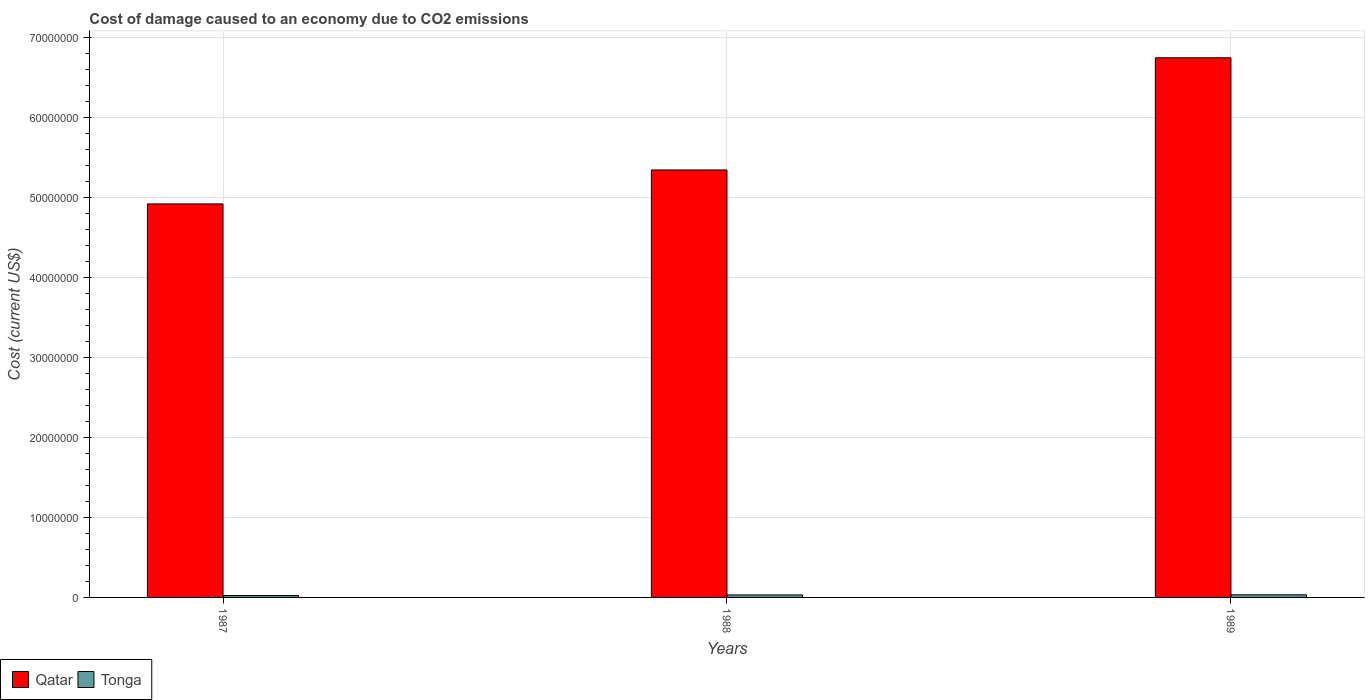How many different coloured bars are there?
Provide a short and direct response. 2. Are the number of bars per tick equal to the number of legend labels?
Make the answer very short. Yes. Are the number of bars on each tick of the X-axis equal?
Provide a succinct answer. Yes. How many bars are there on the 3rd tick from the left?
Ensure brevity in your answer.  2. How many bars are there on the 2nd tick from the right?
Offer a terse response. 2. In how many cases, is the number of bars for a given year not equal to the number of legend labels?
Make the answer very short. 0. What is the cost of damage caused due to CO2 emissisons in Tonga in 1989?
Your answer should be very brief. 3.28e+05. Across all years, what is the maximum cost of damage caused due to CO2 emissisons in Qatar?
Your response must be concise. 6.75e+07. Across all years, what is the minimum cost of damage caused due to CO2 emissisons in Qatar?
Your answer should be compact. 4.92e+07. In which year was the cost of damage caused due to CO2 emissisons in Qatar maximum?
Keep it short and to the point. 1989. In which year was the cost of damage caused due to CO2 emissisons in Qatar minimum?
Give a very brief answer. 1987. What is the total cost of damage caused due to CO2 emissisons in Qatar in the graph?
Give a very brief answer. 1.70e+08. What is the difference between the cost of damage caused due to CO2 emissisons in Qatar in 1987 and that in 1988?
Make the answer very short. -4.24e+06. What is the difference between the cost of damage caused due to CO2 emissisons in Tonga in 1987 and the cost of damage caused due to CO2 emissisons in Qatar in 1989?
Ensure brevity in your answer.  -6.72e+07. What is the average cost of damage caused due to CO2 emissisons in Tonga per year?
Offer a terse response. 2.92e+05. In the year 1989, what is the difference between the cost of damage caused due to CO2 emissisons in Tonga and cost of damage caused due to CO2 emissisons in Qatar?
Give a very brief answer. -6.71e+07. What is the ratio of the cost of damage caused due to CO2 emissisons in Tonga in 1987 to that in 1989?
Offer a very short reply. 0.72. Is the difference between the cost of damage caused due to CO2 emissisons in Tonga in 1988 and 1989 greater than the difference between the cost of damage caused due to CO2 emissisons in Qatar in 1988 and 1989?
Provide a short and direct response. Yes. What is the difference between the highest and the second highest cost of damage caused due to CO2 emissisons in Qatar?
Keep it short and to the point. 1.40e+07. What is the difference between the highest and the lowest cost of damage caused due to CO2 emissisons in Tonga?
Offer a very short reply. 9.28e+04. In how many years, is the cost of damage caused due to CO2 emissisons in Tonga greater than the average cost of damage caused due to CO2 emissisons in Tonga taken over all years?
Offer a very short reply. 2. Is the sum of the cost of damage caused due to CO2 emissisons in Qatar in 1987 and 1988 greater than the maximum cost of damage caused due to CO2 emissisons in Tonga across all years?
Your response must be concise. Yes. What does the 2nd bar from the left in 1988 represents?
Your answer should be very brief. Tonga. What does the 2nd bar from the right in 1987 represents?
Provide a short and direct response. Qatar. Are all the bars in the graph horizontal?
Your answer should be compact. No. How many years are there in the graph?
Offer a terse response. 3. Are the values on the major ticks of Y-axis written in scientific E-notation?
Provide a succinct answer. No. Does the graph contain any zero values?
Keep it short and to the point. No. Does the graph contain grids?
Ensure brevity in your answer.  Yes. How are the legend labels stacked?
Make the answer very short. Horizontal. What is the title of the graph?
Provide a short and direct response. Cost of damage caused to an economy due to CO2 emissions. What is the label or title of the Y-axis?
Provide a succinct answer. Cost (current US$). What is the Cost (current US$) in Qatar in 1987?
Offer a terse response. 4.92e+07. What is the Cost (current US$) in Tonga in 1987?
Provide a succinct answer. 2.35e+05. What is the Cost (current US$) of Qatar in 1988?
Keep it short and to the point. 5.35e+07. What is the Cost (current US$) of Tonga in 1988?
Ensure brevity in your answer.  3.12e+05. What is the Cost (current US$) in Qatar in 1989?
Your answer should be compact. 6.75e+07. What is the Cost (current US$) in Tonga in 1989?
Your answer should be compact. 3.28e+05. Across all years, what is the maximum Cost (current US$) of Qatar?
Your answer should be compact. 6.75e+07. Across all years, what is the maximum Cost (current US$) of Tonga?
Make the answer very short. 3.28e+05. Across all years, what is the minimum Cost (current US$) in Qatar?
Ensure brevity in your answer.  4.92e+07. Across all years, what is the minimum Cost (current US$) in Tonga?
Provide a short and direct response. 2.35e+05. What is the total Cost (current US$) of Qatar in the graph?
Your answer should be compact. 1.70e+08. What is the total Cost (current US$) in Tonga in the graph?
Make the answer very short. 8.76e+05. What is the difference between the Cost (current US$) of Qatar in 1987 and that in 1988?
Your response must be concise. -4.24e+06. What is the difference between the Cost (current US$) of Tonga in 1987 and that in 1988?
Provide a succinct answer. -7.68e+04. What is the difference between the Cost (current US$) in Qatar in 1987 and that in 1989?
Your answer should be compact. -1.83e+07. What is the difference between the Cost (current US$) in Tonga in 1987 and that in 1989?
Give a very brief answer. -9.28e+04. What is the difference between the Cost (current US$) in Qatar in 1988 and that in 1989?
Give a very brief answer. -1.40e+07. What is the difference between the Cost (current US$) of Tonga in 1988 and that in 1989?
Your answer should be compact. -1.59e+04. What is the difference between the Cost (current US$) in Qatar in 1987 and the Cost (current US$) in Tonga in 1988?
Your answer should be compact. 4.89e+07. What is the difference between the Cost (current US$) of Qatar in 1987 and the Cost (current US$) of Tonga in 1989?
Keep it short and to the point. 4.89e+07. What is the difference between the Cost (current US$) of Qatar in 1988 and the Cost (current US$) of Tonga in 1989?
Your answer should be compact. 5.31e+07. What is the average Cost (current US$) of Qatar per year?
Ensure brevity in your answer.  5.67e+07. What is the average Cost (current US$) in Tonga per year?
Make the answer very short. 2.92e+05. In the year 1987, what is the difference between the Cost (current US$) in Qatar and Cost (current US$) in Tonga?
Give a very brief answer. 4.90e+07. In the year 1988, what is the difference between the Cost (current US$) of Qatar and Cost (current US$) of Tonga?
Make the answer very short. 5.31e+07. In the year 1989, what is the difference between the Cost (current US$) in Qatar and Cost (current US$) in Tonga?
Your answer should be very brief. 6.71e+07. What is the ratio of the Cost (current US$) in Qatar in 1987 to that in 1988?
Give a very brief answer. 0.92. What is the ratio of the Cost (current US$) in Tonga in 1987 to that in 1988?
Give a very brief answer. 0.75. What is the ratio of the Cost (current US$) in Qatar in 1987 to that in 1989?
Your answer should be very brief. 0.73. What is the ratio of the Cost (current US$) of Tonga in 1987 to that in 1989?
Provide a short and direct response. 0.72. What is the ratio of the Cost (current US$) of Qatar in 1988 to that in 1989?
Keep it short and to the point. 0.79. What is the ratio of the Cost (current US$) of Tonga in 1988 to that in 1989?
Keep it short and to the point. 0.95. What is the difference between the highest and the second highest Cost (current US$) of Qatar?
Offer a terse response. 1.40e+07. What is the difference between the highest and the second highest Cost (current US$) of Tonga?
Keep it short and to the point. 1.59e+04. What is the difference between the highest and the lowest Cost (current US$) in Qatar?
Your answer should be compact. 1.83e+07. What is the difference between the highest and the lowest Cost (current US$) in Tonga?
Your answer should be compact. 9.28e+04. 